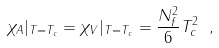<formula> <loc_0><loc_0><loc_500><loc_500>\chi _ { A } | _ { T = T _ { c } } = \chi _ { V } | _ { T = T _ { c } } = \frac { N _ { f } ^ { 2 } } { 6 } T _ { c } ^ { 2 } \ ,</formula> 